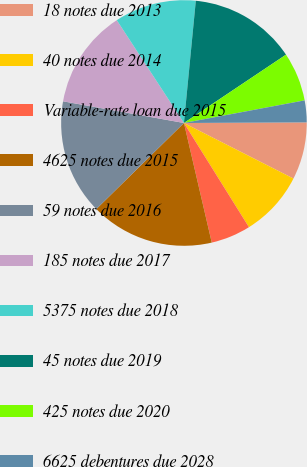Convert chart. <chart><loc_0><loc_0><loc_500><loc_500><pie_chart><fcel>18 notes due 2013<fcel>40 notes due 2014<fcel>Variable-rate loan due 2015<fcel>4625 notes due 2015<fcel>59 notes due 2016<fcel>185 notes due 2017<fcel>5375 notes due 2018<fcel>45 notes due 2019<fcel>425 notes due 2020<fcel>6625 debentures due 2028<nl><fcel>7.55%<fcel>8.65%<fcel>5.24%<fcel>16.28%<fcel>15.18%<fcel>12.97%<fcel>10.75%<fcel>14.07%<fcel>6.44%<fcel>2.87%<nl></chart> 